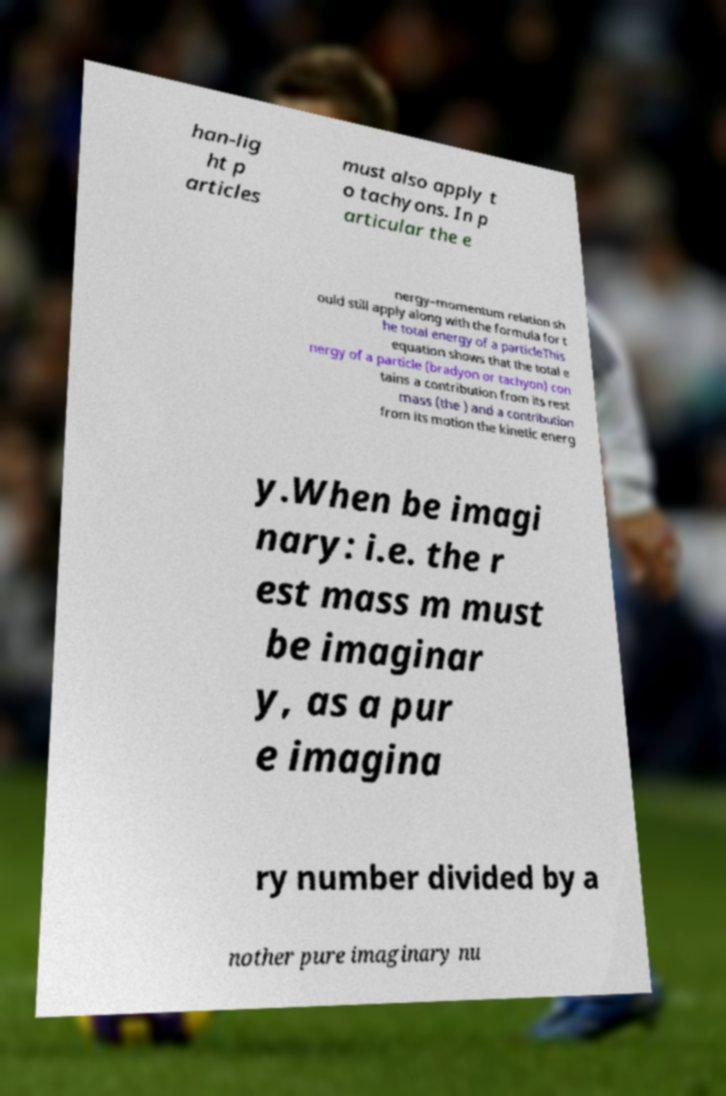Please read and relay the text visible in this image. What does it say? han-lig ht p articles must also apply t o tachyons. In p articular the e nergy–momentum relation sh ould still apply along with the formula for t he total energy of a particleThis equation shows that the total e nergy of a particle (bradyon or tachyon) con tains a contribution from its rest mass (the ) and a contribution from its motion the kinetic energ y.When be imagi nary: i.e. the r est mass m must be imaginar y, as a pur e imagina ry number divided by a nother pure imaginary nu 